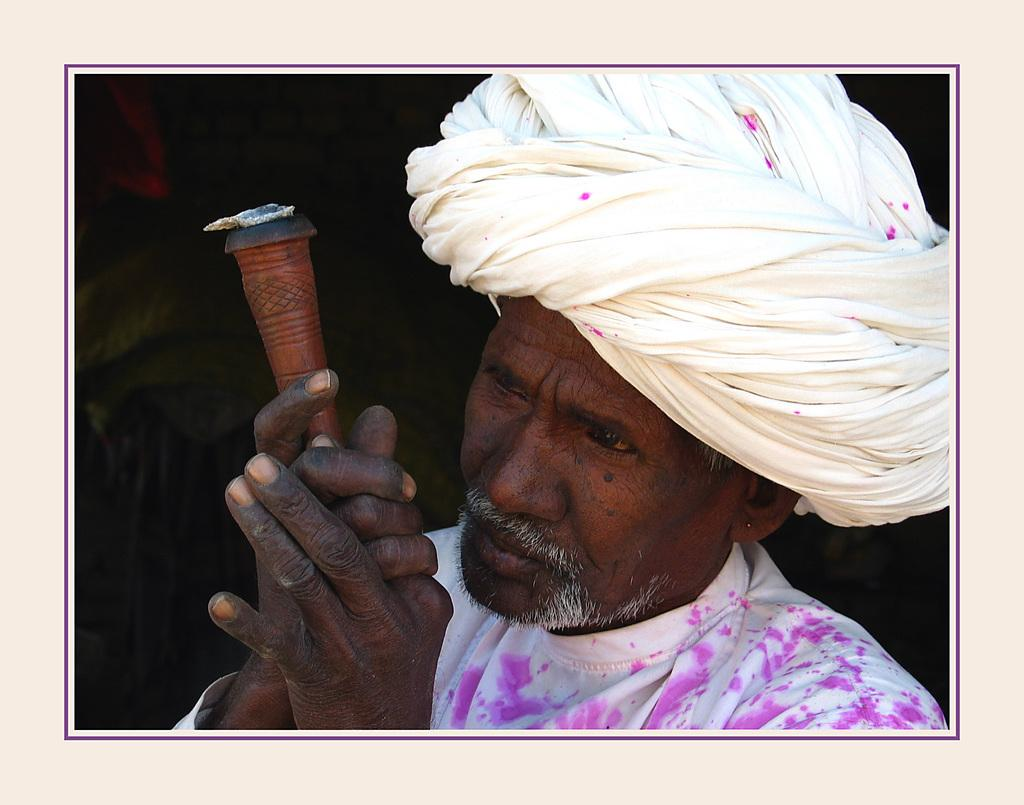What object can be seen in the image? There is a photo frame in the image. Who is present in the image? There is a man in the image. What is the man holding in his hand? The man is holding an object in his hand. What color is the background of the image? The background of the image is black. How many baskets are visible in the image? There are no baskets present in the image. What type of shirt is the man wearing in the image? The provided facts do not mention the man's shirt, so we cannot determine the type of shirt he is wearing. 